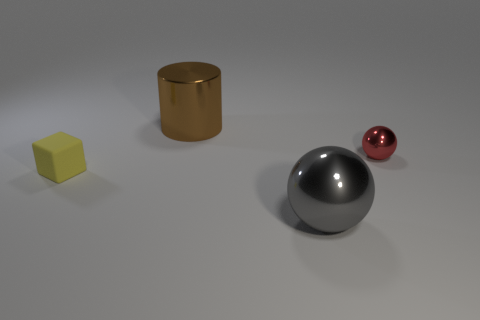Add 3 purple metallic cylinders. How many objects exist? 7 Subtract all gray balls. How many balls are left? 1 Subtract all cubes. How many objects are left? 3 Subtract 2 balls. How many balls are left? 0 Subtract all yellow cylinders. How many red balls are left? 1 Subtract all large brown shiny things. Subtract all blue matte cylinders. How many objects are left? 3 Add 1 small metallic objects. How many small metallic objects are left? 2 Add 4 tiny red metal balls. How many tiny red metal balls exist? 5 Subtract 0 cyan balls. How many objects are left? 4 Subtract all red balls. Subtract all yellow cylinders. How many balls are left? 1 